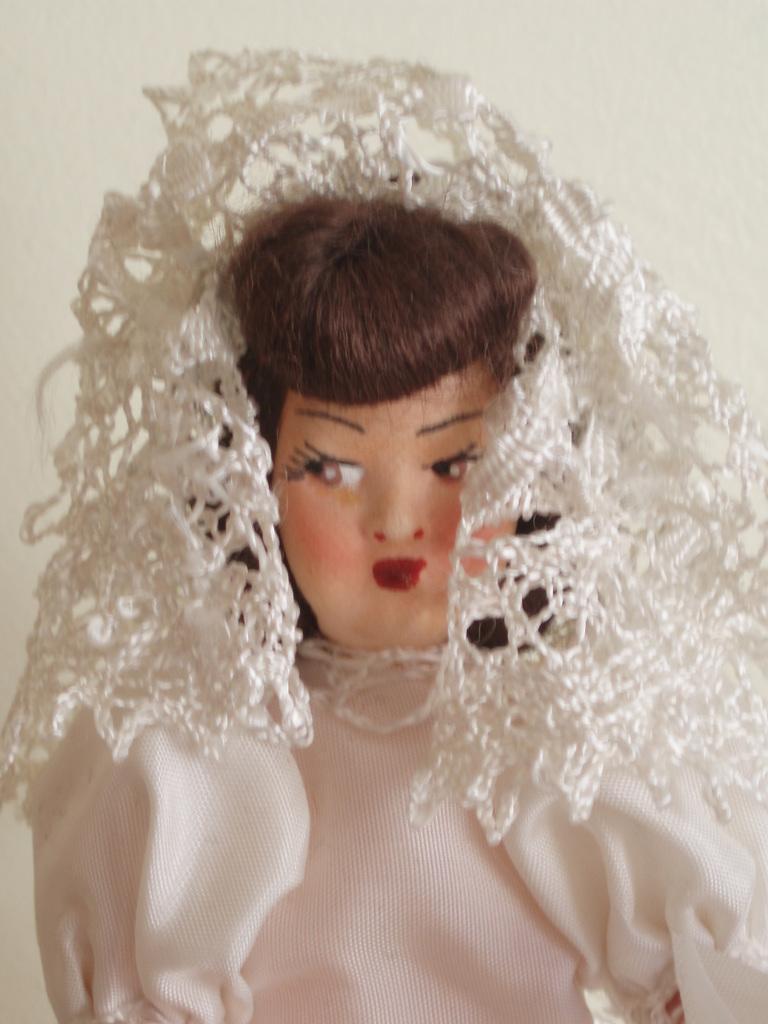How would you summarize this image in a sentence or two? In the center of the image there is a doll. In the background we can see wall. 